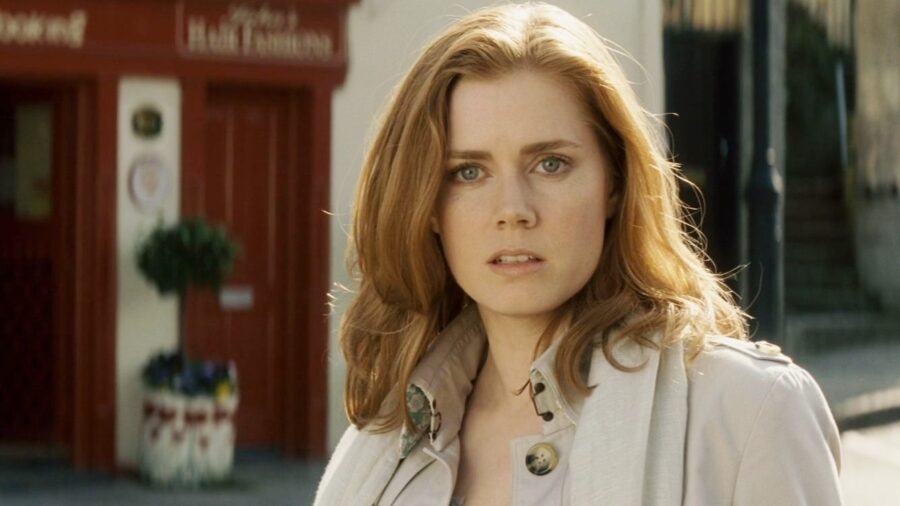Describe the fashion sense of the woman in the image. The woman in the image showcases a sophisticated and refined fashion sense. She is wearing a chic beige trench coat, a staple piece for a polished and classic look. The trench coat is accentuated with a lovely brooch on the lapel, adding a touch of elegance and personal style. Her overall appearance combines timeless fashion elements with a modern twist, making it both stylish and understated. How does her appearance enhance the overall mood of the picture? Her appearance significantly enhances the overall mood of the picture. The beige trench coat exudes sophistication and matches the city's stylish and refined atmosphere. Her relaxed yet introspective expression adds a layer of depth and emotion, drawing the viewer into her contemplative state. Together with the vibrant red storefront and the lush green plant, her presence brings a harmonious blend of elegance, thoughts, and emotion to the scene. 